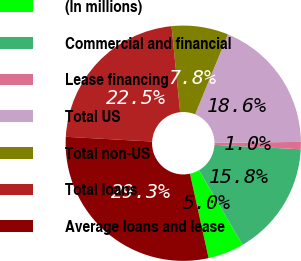Convert chart. <chart><loc_0><loc_0><loc_500><loc_500><pie_chart><fcel>(In millions)<fcel>Commercial and financial<fcel>Lease financing<fcel>Total US<fcel>Total non-US<fcel>Total loans<fcel>Average loans and lease<nl><fcel>4.95%<fcel>15.78%<fcel>1.0%<fcel>18.62%<fcel>7.79%<fcel>22.53%<fcel>29.32%<nl></chart> 